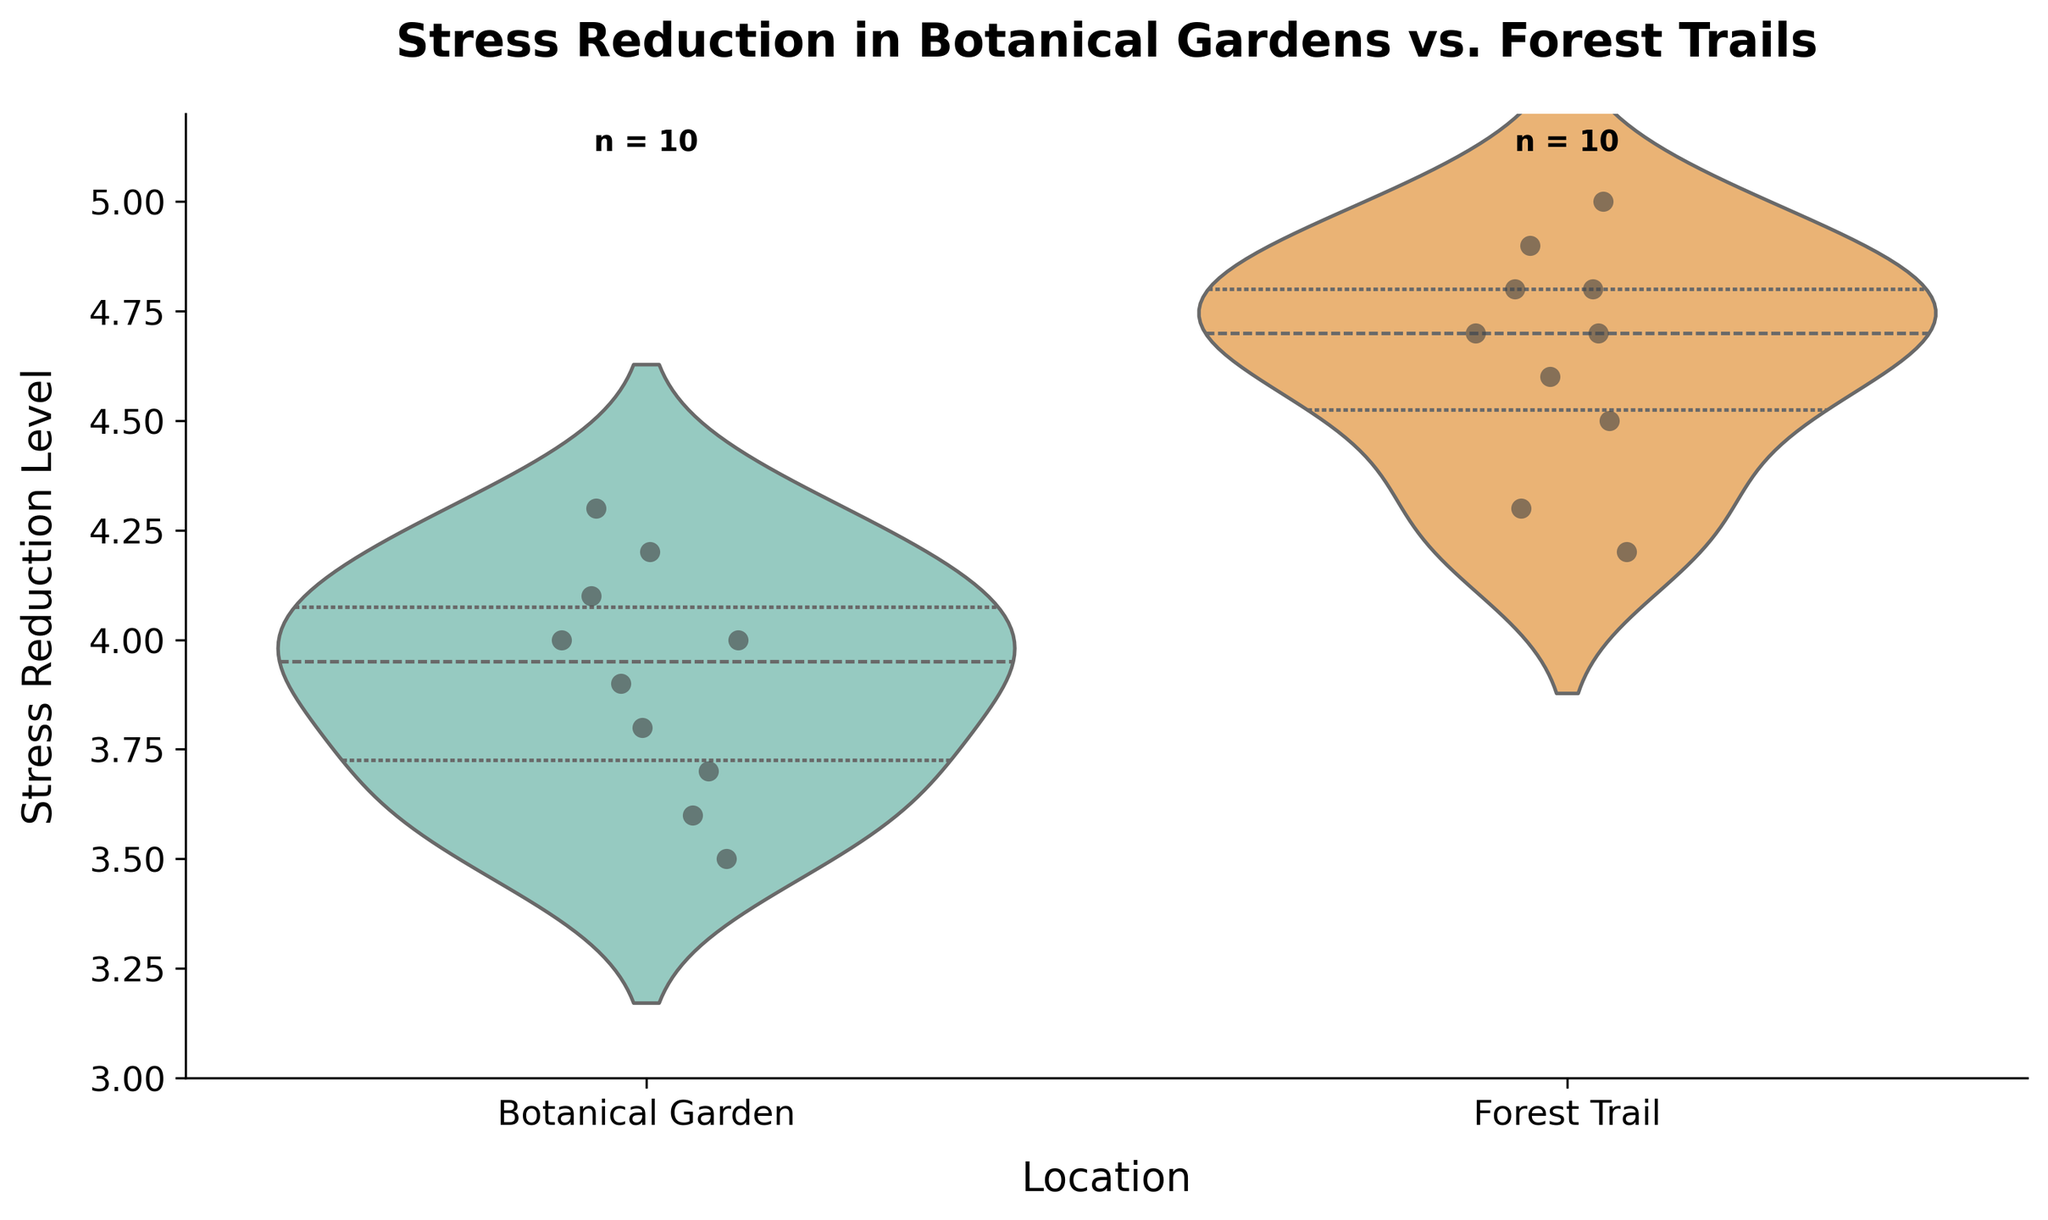What is the title of the figure? The title of the figure is usually displayed at the top of the plot. It is set to provide a general overview of what the graph is representing. In this case, it is directly visible above the plot.
Answer: Stress Reduction in Botanical Gardens vs. Forest Trails What is the range of Stress Reduction levels shown on the y-axis? The y-axis range is seen on the left side of the plot. The minimum value is marked at the bottom, and the maximum value is at the top. We can infer these values from the visual ticks on the axis.
Answer: 3 to 5.2 How many data points are represented in the Botanical Garden category? The number of data points for each category is typically indicated in the figure. Here, it's directly noted above the respective violin plot for the Botanical Garden.
Answer: 10 Which location has the higher average stress reduction? To determine the higher average, visually compare the central tendency (usually the thicker part of the violin plot) of each location. The Forest Trail plot appears to be slightly higher.
Answer: Forest Trail What does the color represent in the violin plot? Colors usually differentiate between categories. The two different colors here distinguish the Botanical Garden from the Forest Trail. Botanical Garden is light blue, and Forest Trail is light orange.
Answer: Different locations On which location's violin plot are the jittered points more dispersed? Jittered points show individual data points spread out within each violin plot. Visually compare the dispersion width of the points in both categories.
Answer: Forest Trail What is the median stress reduction level in the Botanical Garden? The median value is indicated by a line inside the violin plot's body. For the Botanical Garden, find that line within its range.
Answer: Approximately 4.0 Which location has a wider spread of stress reduction values? The spread of values is more comprehensive if the violin plot covers a larger vertical range. Visual comparison shows which plot is more vertically spread.
Answer: Forest Trail What pattern is denoted by the inner markings of the violin plots? Inner markings in violin plots typically represent statistical metrics such as quartiles and medians. In this plot, they indicate quartiles.
Answer: Quartiles Which location indicates more variability in stress reduction levels? Variability can be inferred from the violin plot's width and how spread out the jittered points are. The plot with a broader base and more dispersed points indicates more variability.
Answer: Forest Trail 